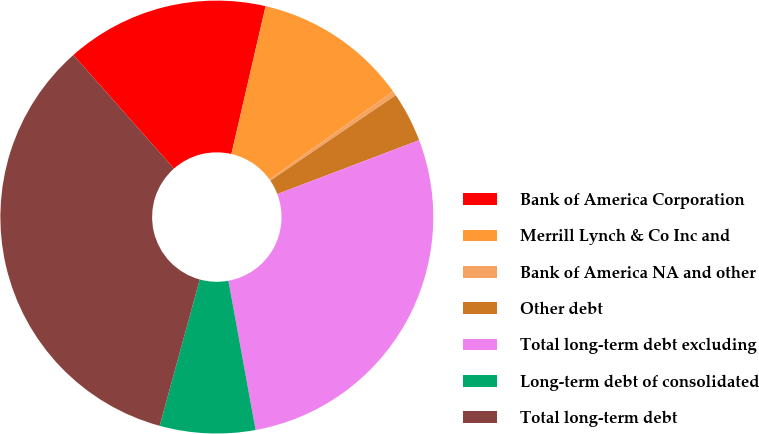Convert chart. <chart><loc_0><loc_0><loc_500><loc_500><pie_chart><fcel>Bank of America Corporation<fcel>Merrill Lynch & Co Inc and<fcel>Bank of America NA and other<fcel>Other debt<fcel>Total long-term debt excluding<fcel>Long-term debt of consolidated<fcel>Total long-term debt<nl><fcel>15.15%<fcel>11.52%<fcel>0.35%<fcel>3.73%<fcel>27.91%<fcel>7.12%<fcel>34.21%<nl></chart> 